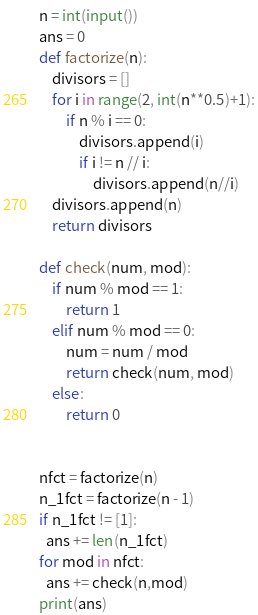Convert code to text. <code><loc_0><loc_0><loc_500><loc_500><_Python_>n = int(input())
ans = 0
def factorize(n):
    divisors = []
    for i in range(2, int(n**0.5)+1):
        if n % i == 0:
            divisors.append(i)
            if i != n // i:
                divisors.append(n//i)
    divisors.append(n)
    return divisors

def check(num, mod):
    if num % mod == 1:
        return 1
    elif num % mod == 0:
        num = num / mod
        return check(num, mod)
    else:
        return 0


nfct = factorize(n)
n_1fct = factorize(n - 1)
if n_1fct != [1]:
  ans += len(n_1fct)
for mod in nfct:
  ans += check(n,mod)
print(ans)
</code> 